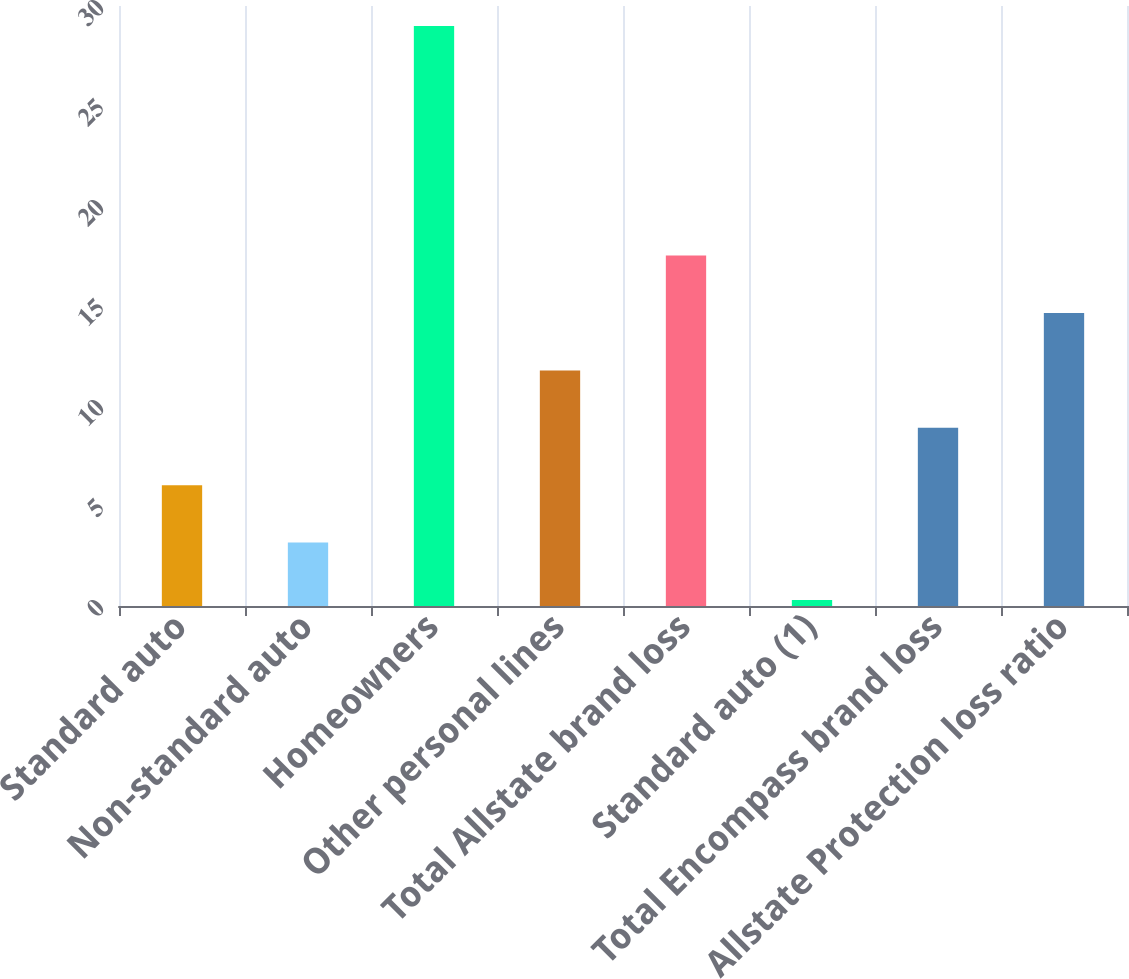Convert chart to OTSL. <chart><loc_0><loc_0><loc_500><loc_500><bar_chart><fcel>Standard auto<fcel>Non-standard auto<fcel>Homeowners<fcel>Other personal lines<fcel>Total Allstate brand loss<fcel>Standard auto (1)<fcel>Total Encompass brand loss<fcel>Allstate Protection loss ratio<nl><fcel>6.04<fcel>3.17<fcel>29<fcel>11.78<fcel>17.52<fcel>0.3<fcel>8.91<fcel>14.65<nl></chart> 